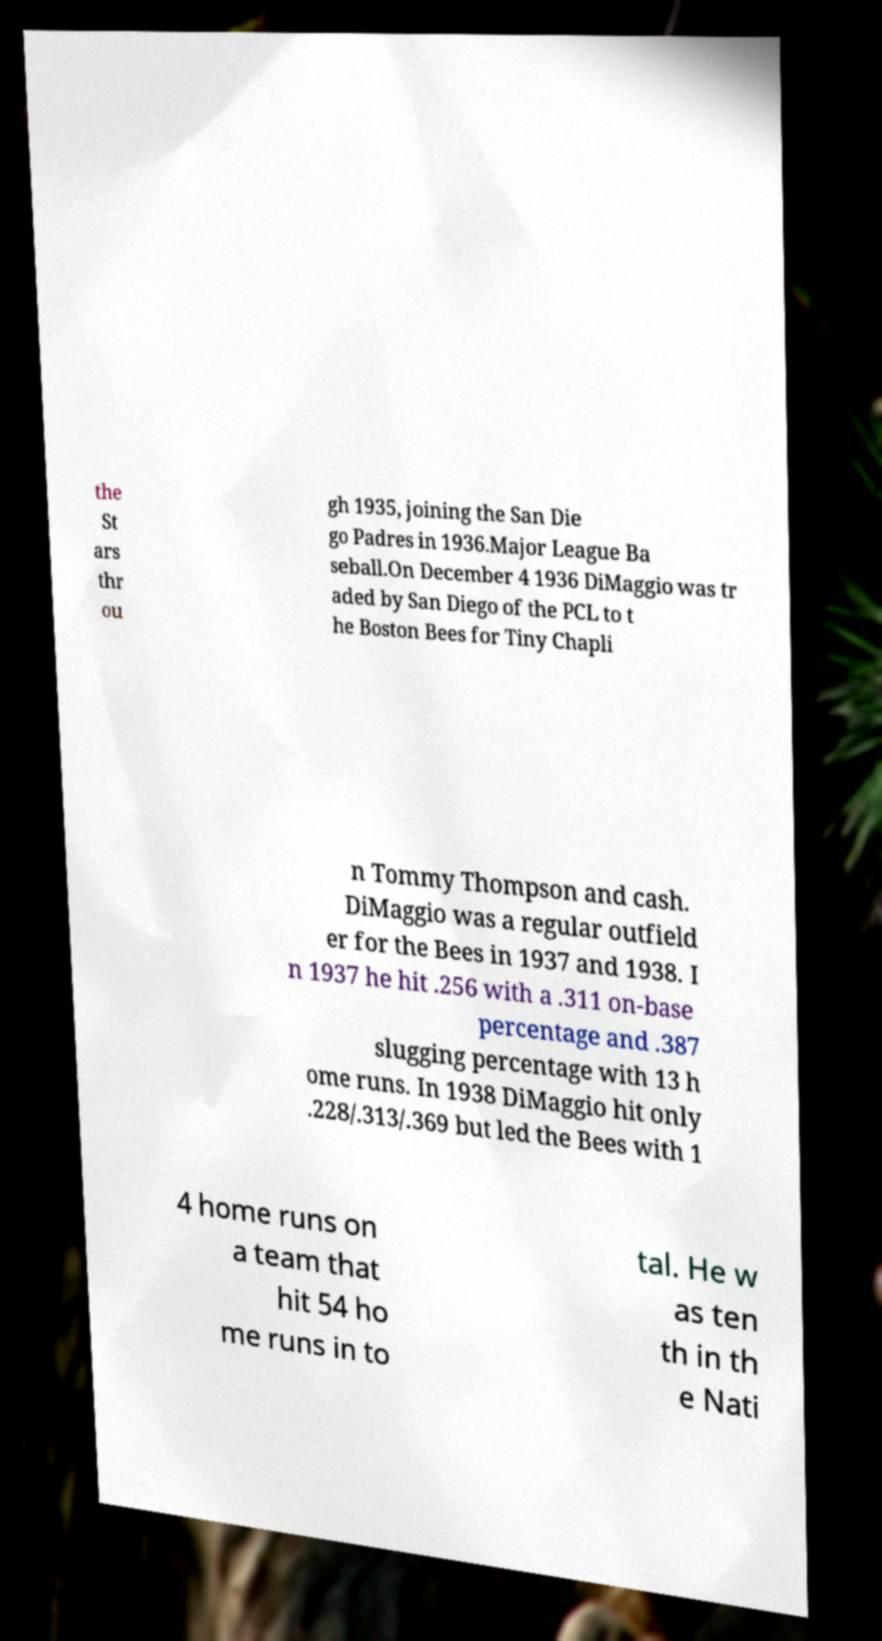There's text embedded in this image that I need extracted. Can you transcribe it verbatim? the St ars thr ou gh 1935, joining the San Die go Padres in 1936.Major League Ba seball.On December 4 1936 DiMaggio was tr aded by San Diego of the PCL to t he Boston Bees for Tiny Chapli n Tommy Thompson and cash. DiMaggio was a regular outfield er for the Bees in 1937 and 1938. I n 1937 he hit .256 with a .311 on-base percentage and .387 slugging percentage with 13 h ome runs. In 1938 DiMaggio hit only .228/.313/.369 but led the Bees with 1 4 home runs on a team that hit 54 ho me runs in to tal. He w as ten th in th e Nati 